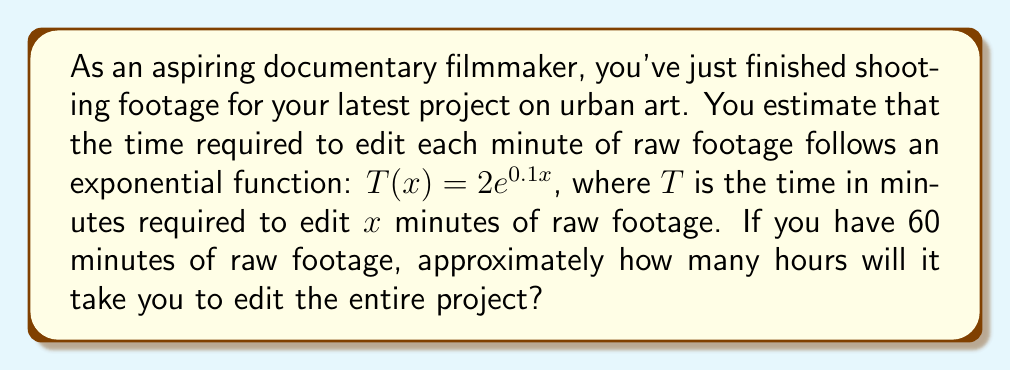Teach me how to tackle this problem. To solve this problem, we'll follow these steps:

1) We're given the function $T(x) = 2e^{0.1x}$, where $T$ is the editing time in minutes for $x$ minutes of raw footage.

2) We need to find $T(60)$, as we have 60 minutes of raw footage:

   $T(60) = 2e^{0.1(60)}$

3) Let's calculate this:
   
   $T(60) = 2e^6$
   
   $= 2 \cdot (e^6)$
   
   $\approx 2 \cdot 403.4287935$
   
   $\approx 806.8575870$ minutes

4) To convert this to hours, we divide by 60:

   $\frac{806.8575870}{60} \approx 13.4476$ hours

5) Rounding to the nearest quarter hour:

   $13.4476$ hours $\approx 13.5$ hours
Answer: Approximately 13.5 hours 